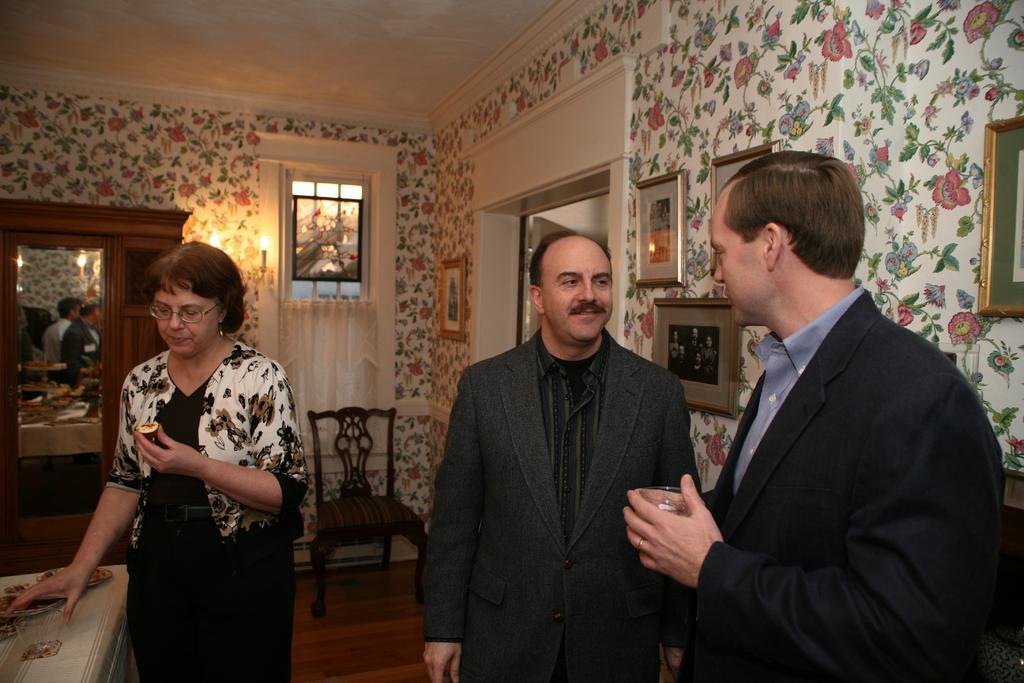Could you give a brief overview of what you see in this image? In this image in the foreground there are three persons standing, and on the left side there is one table. On the table there are some plates and one person is holding a glass, and one person is holding something. In the background there is a chair, mirror, cupboard, window and some photo frames on the wall. At the bottom there is floor. 